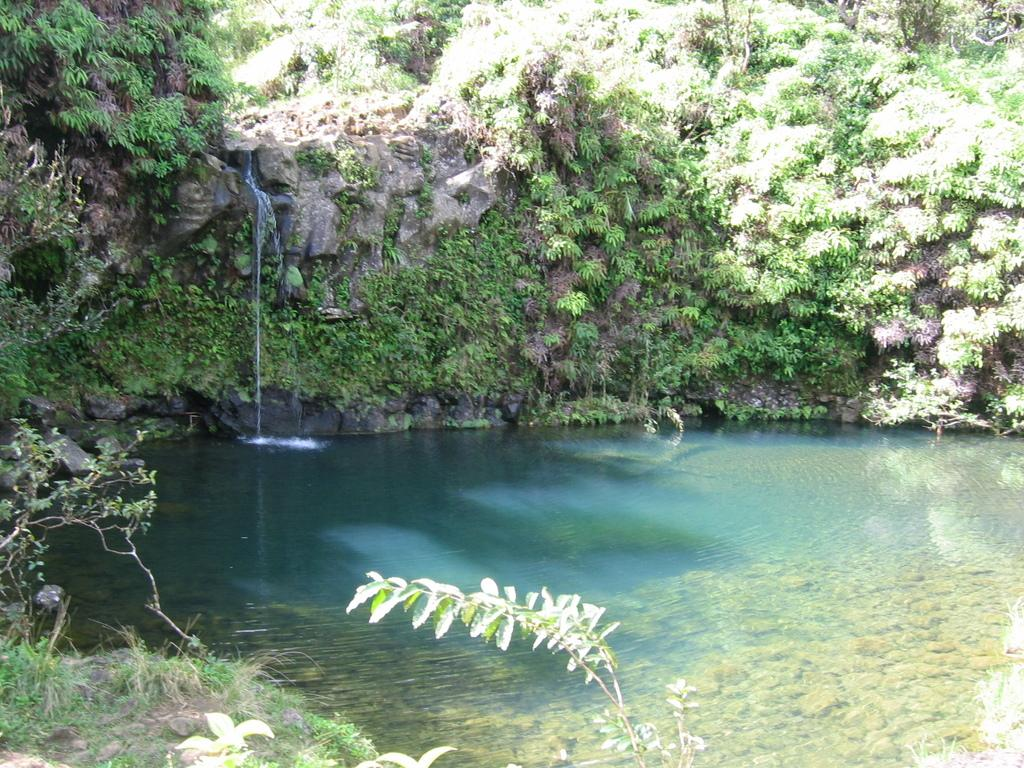What is one of the natural elements present in the image? There is water in the image. What type of vegetation can be seen in the image? There is grass and plants in the image. What can be seen in the background of the image? There is a rock mountain in the background of the image. How large is the rock mountain? The rock mountain is huge. What type of vegetation is present on the rock mountain? There are trees on the rock mountain, and they are green in color. How does the society in the image react to the parcel being pushed? There is no society or parcel present in the image; it features natural elements such as water, grass, plants, and a rock mountain. 